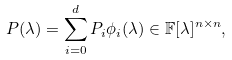<formula> <loc_0><loc_0><loc_500><loc_500>P ( \lambda ) = \sum _ { i = 0 } ^ { d } P _ { i } \phi _ { i } ( \lambda ) \in \mathbb { F } [ \lambda ] ^ { n \times n } ,</formula> 